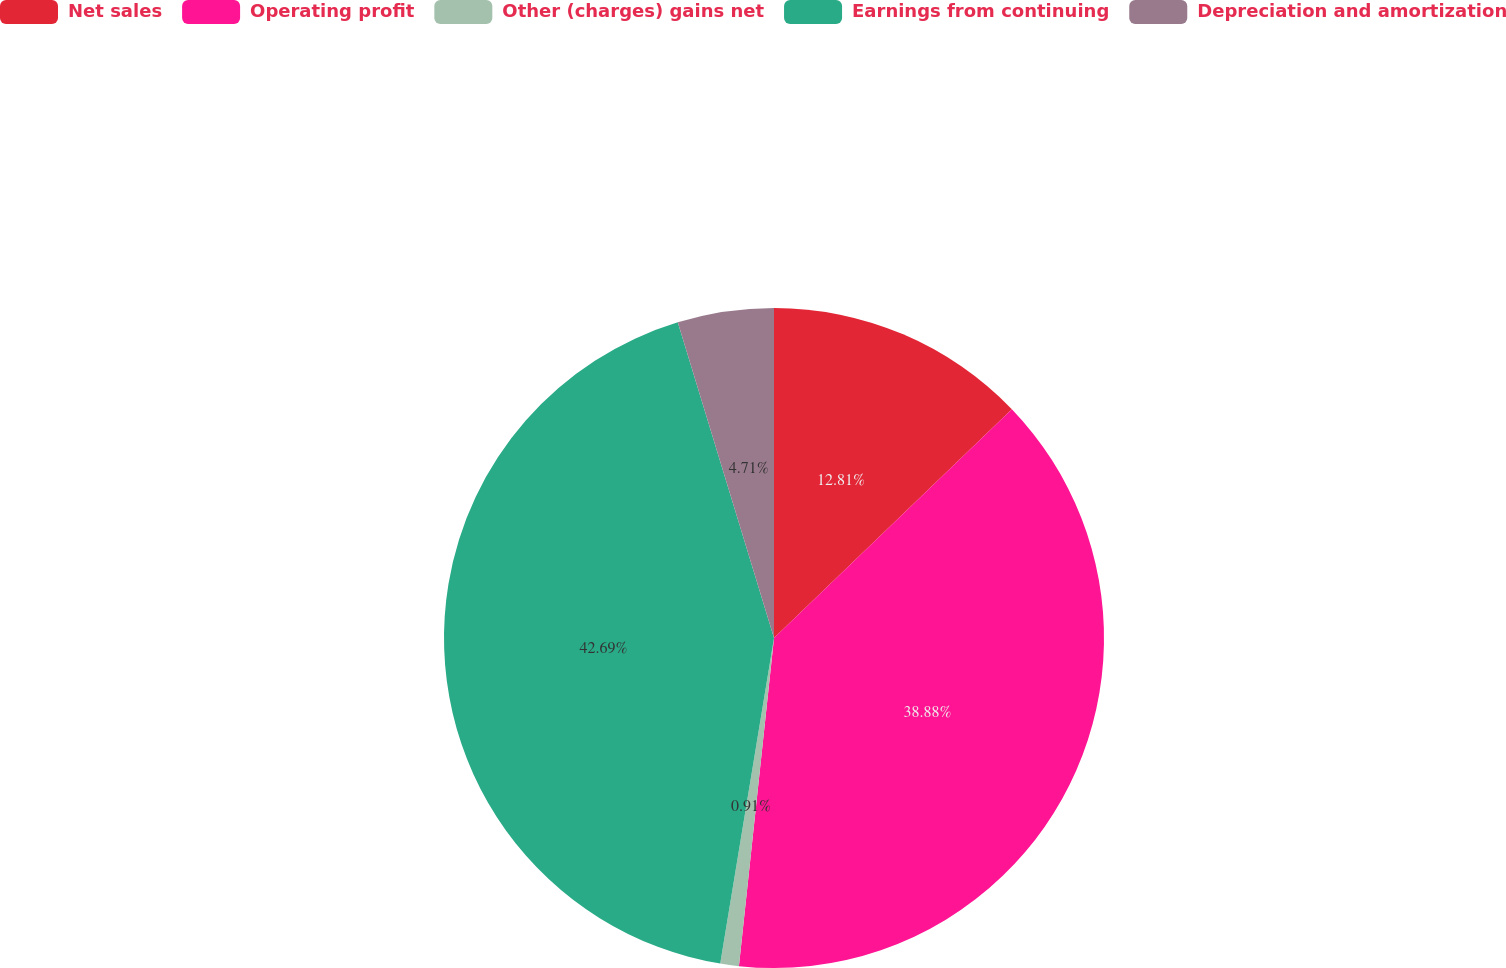Convert chart to OTSL. <chart><loc_0><loc_0><loc_500><loc_500><pie_chart><fcel>Net sales<fcel>Operating profit<fcel>Other (charges) gains net<fcel>Earnings from continuing<fcel>Depreciation and amortization<nl><fcel>12.81%<fcel>38.88%<fcel>0.91%<fcel>42.68%<fcel>4.71%<nl></chart> 